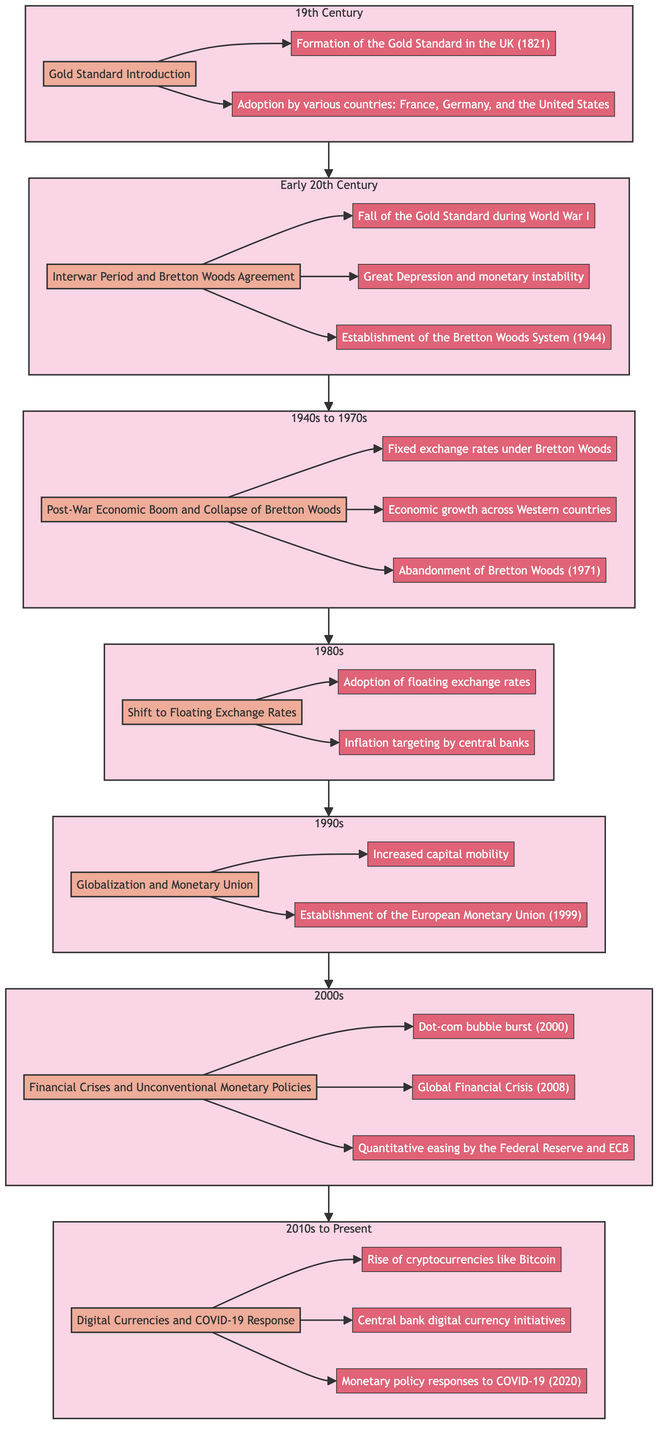What is the highest period represented in the diagram? The diagram flows from the bottom to the top, with the highest period being the most recent one at the top. The top node is "2010s to Present", indicating that it encompasses the most current development in monetary policies.
Answer: 2010s to Present How many key events are listed for the "Post-War Economic Boom and Collapse of Bretton Woods"? To find the number of key events, we look at the node "Post-War Economic Boom and Collapse of Bretton Woods". It is connected to three events: "Fixed exchange rates under Bretton Woods", "Economic growth across Western countries", and "Abandonment of Bretton Woods (1971)". Therefore, the count is three.
Answer: 3 What significant monetary event occurred in 1944? We need to focus on the period "Interwar Period and Bretton Woods Agreement", where one of the key events is explicitly mentioned as the "Establishment of the Bretton Woods System (1944)". This clearly identifies the significant event in that year.
Answer: Establishment of the Bretton Woods System Which period directly follows the "1980s" in the flow chart? In the flow chart, we can trace the arrows pointing up from the "1980s" node. The very next node above it is "1990s", establishing it as the period that follows directly after the 1980s.
Answer: 1990s What type of exchange rate was adopted in the 1980s? The node for the "1980s" indicates a shift to floating exchange rates. This means that the exchange rate was no longer fixed and began to fluctuate according to market dynamics.
Answer: Floating exchange rates How many sub-periods exist in the flow chart? The flow chart has a single main period at each level, with the periods being: "19th Century", "Early 20th Century", "1940s to 1970s", "1980s", "1990s", "2000s", and "2010s to Present". Counting these gives us a total of seven distinct sub-periods across the timeline.
Answer: 7 